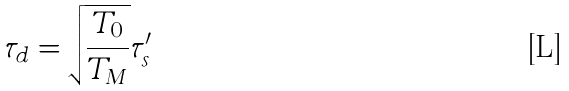Convert formula to latex. <formula><loc_0><loc_0><loc_500><loc_500>\tau _ { d } = \sqrt { \frac { T _ { 0 } } { T _ { M } } } \tau ^ { \prime } _ { s }</formula> 